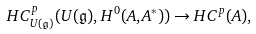<formula> <loc_0><loc_0><loc_500><loc_500>H C ^ { p } _ { U ( \mathfrak { g } ) } ( U ( \mathfrak { g } ) , H ^ { 0 } ( A , A ^ { * } ) ) \rightarrow H C ^ { p } ( A ) ,</formula> 